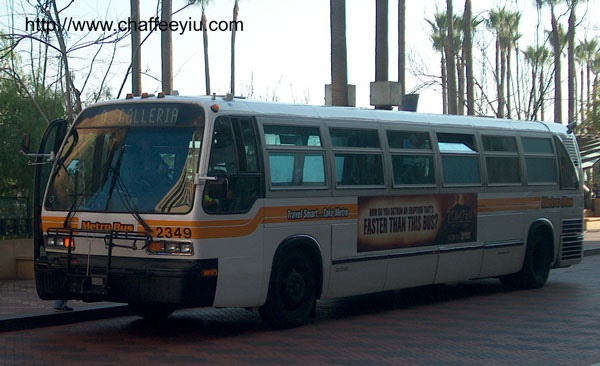Describe the objects in this image and their specific colors. I can see bus in white, black, purple, and darkblue tones in this image. 